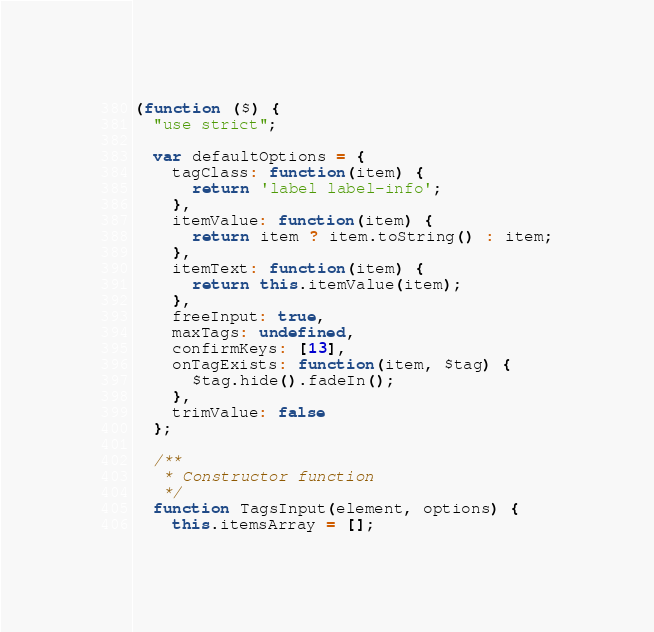Convert code to text. <code><loc_0><loc_0><loc_500><loc_500><_JavaScript_>(function ($) {
  "use strict";

  var defaultOptions = {
    tagClass: function(item) {
      return 'label label-info';
    },
    itemValue: function(item) {
      return item ? item.toString() : item;
    },
    itemText: function(item) {
      return this.itemValue(item);
    },
    freeInput: true,
    maxTags: undefined,
    confirmKeys: [13],
    onTagExists: function(item, $tag) {
      $tag.hide().fadeIn();
    },
    trimValue: false
  };

  /**
   * Constructor function
   */
  function TagsInput(element, options) {
    this.itemsArray = [];
</code> 